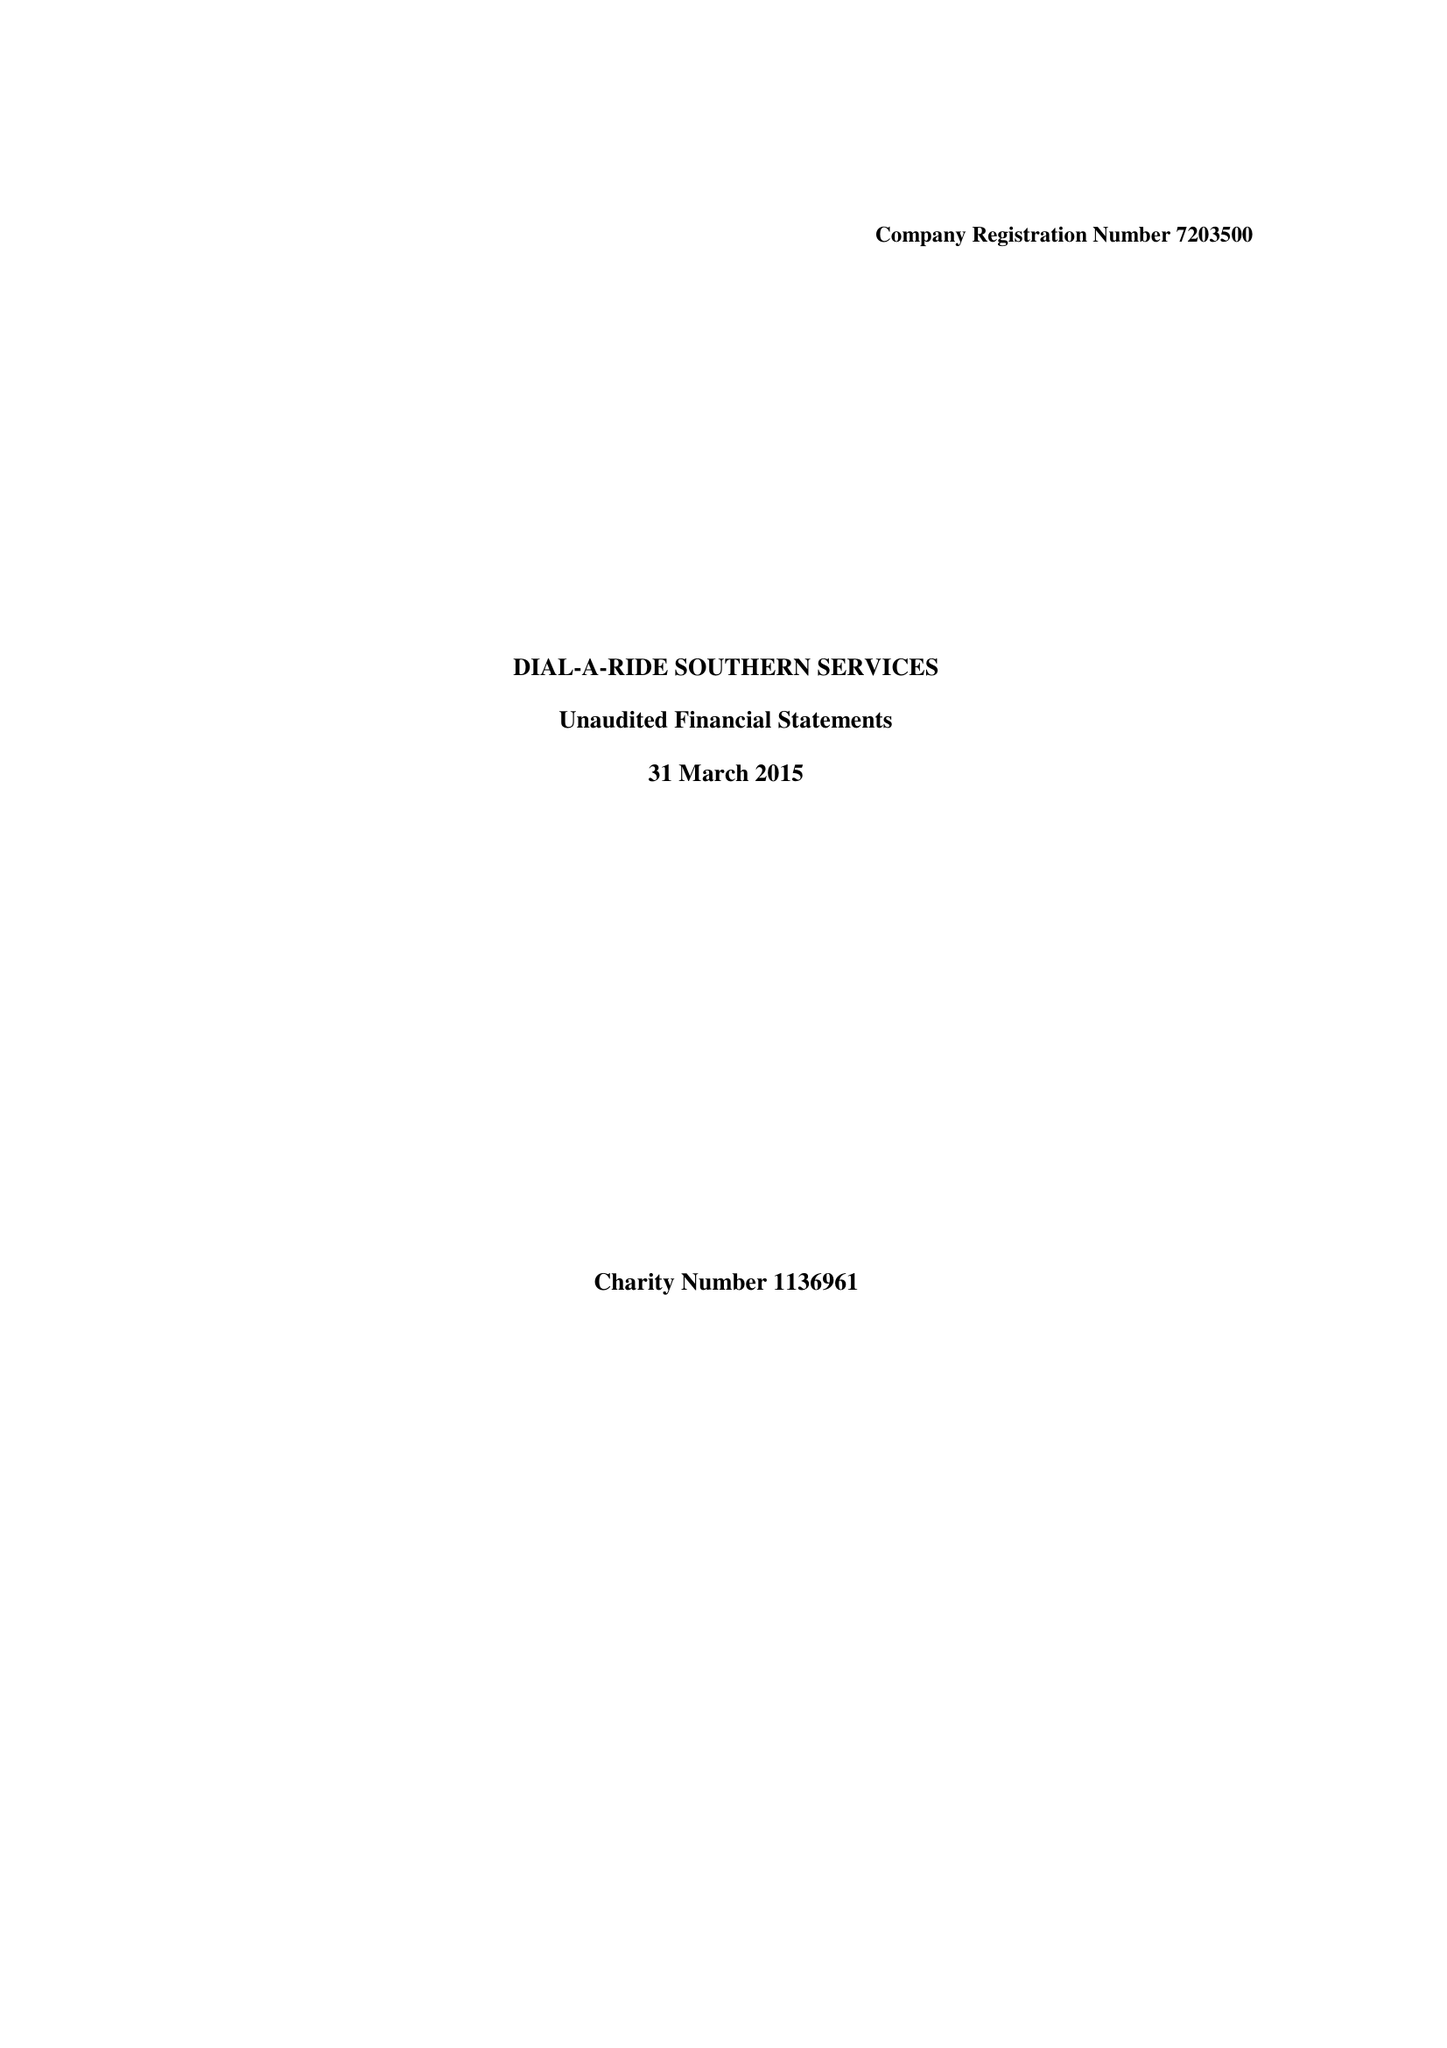What is the value for the address__post_town?
Answer the question using a single word or phrase. WORTHING 